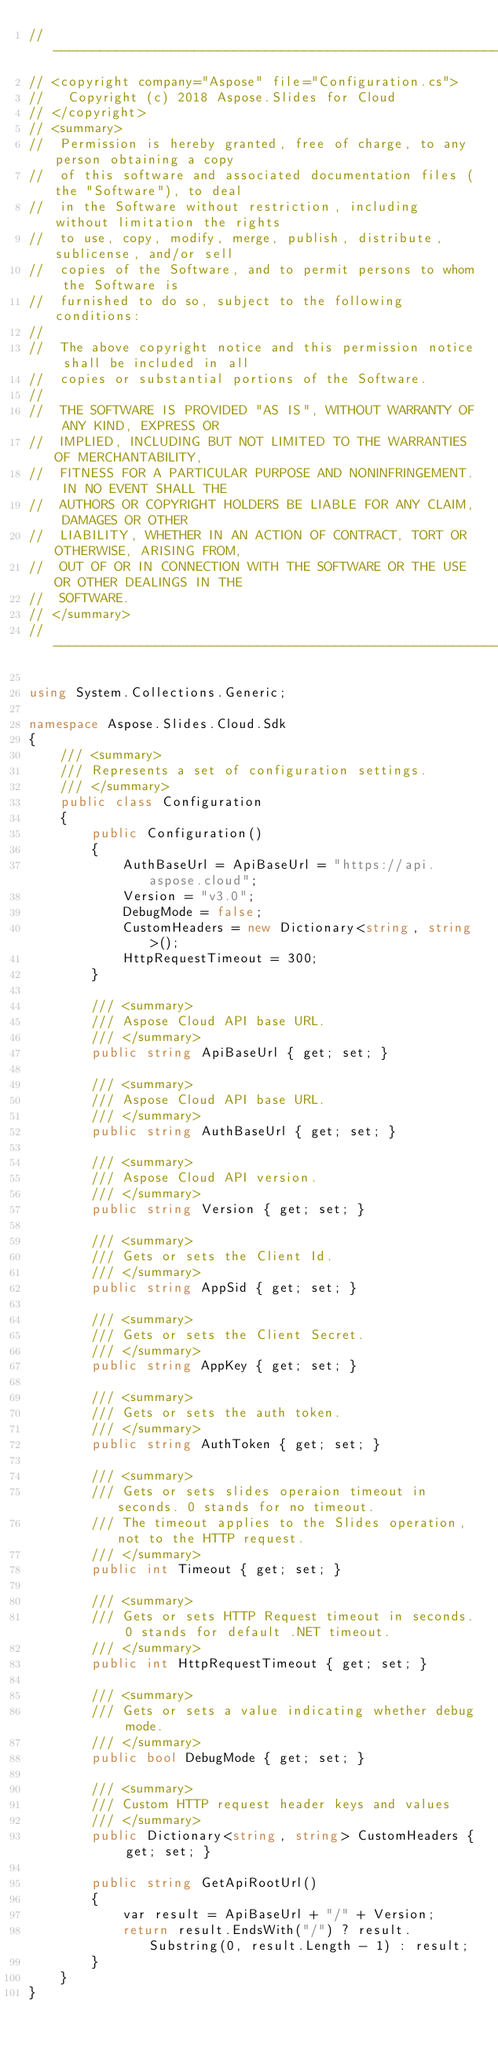<code> <loc_0><loc_0><loc_500><loc_500><_C#_>// --------------------------------------------------------------------------------------------------------------------
// <copyright company="Aspose" file="Configuration.cs">
//   Copyright (c) 2018 Aspose.Slides for Cloud
// </copyright>
// <summary>
//  Permission is hereby granted, free of charge, to any person obtaining a copy
//  of this software and associated documentation files (the "Software"), to deal
//  in the Software without restriction, including without limitation the rights
//  to use, copy, modify, merge, publish, distribute, sublicense, and/or sell
//  copies of the Software, and to permit persons to whom the Software is
//  furnished to do so, subject to the following conditions:
// 
//  The above copyright notice and this permission notice shall be included in all
//  copies or substantial portions of the Software.
// 
//  THE SOFTWARE IS PROVIDED "AS IS", WITHOUT WARRANTY OF ANY KIND, EXPRESS OR
//  IMPLIED, INCLUDING BUT NOT LIMITED TO THE WARRANTIES OF MERCHANTABILITY,
//  FITNESS FOR A PARTICULAR PURPOSE AND NONINFRINGEMENT. IN NO EVENT SHALL THE
//  AUTHORS OR COPYRIGHT HOLDERS BE LIABLE FOR ANY CLAIM, DAMAGES OR OTHER
//  LIABILITY, WHETHER IN AN ACTION OF CONTRACT, TORT OR OTHERWISE, ARISING FROM,
//  OUT OF OR IN CONNECTION WITH THE SOFTWARE OR THE USE OR OTHER DEALINGS IN THE
//  SOFTWARE.
// </summary>
// --------------------------------------------------------------------------------------------------------------------

using System.Collections.Generic;

namespace Aspose.Slides.Cloud.Sdk
{
    /// <summary>
    /// Represents a set of configuration settings.
    /// </summary>
    public class Configuration
    {
        public Configuration()
        {
            AuthBaseUrl = ApiBaseUrl = "https://api.aspose.cloud";
            Version = "v3.0";
            DebugMode = false;
            CustomHeaders = new Dictionary<string, string>();
            HttpRequestTimeout = 300;
        }

        /// <summary>
        /// Aspose Cloud API base URL.
        /// </summary>
        public string ApiBaseUrl { get; set; }

        /// <summary>
        /// Aspose Cloud API base URL.
        /// </summary>
        public string AuthBaseUrl { get; set; }

        /// <summary>
        /// Aspose Cloud API version.
        /// </summary>
        public string Version { get; set; }

        /// <summary>
        /// Gets or sets the Client Id.
        /// </summary>
        public string AppSid { get; set; }

        /// <summary>
        /// Gets or sets the Client Secret.
        /// </summary>
        public string AppKey { get; set; }

        /// <summary>
        /// Gets or sets the auth token.
        /// </summary>
        public string AuthToken { get; set; }

        /// <summary>
        /// Gets or sets slides operaion timeout in seconds. 0 stands for no timeout.
        /// The timeout applies to the Slides operation, not to the HTTP request.
        /// </summary>
        public int Timeout { get; set; }

        /// <summary>
        /// Gets or sets HTTP Request timeout in seconds. 0 stands for default .NET timeout.
        /// </summary>
        public int HttpRequestTimeout { get; set; }

        /// <summary>
        /// Gets or sets a value indicating whether debug mode.
        /// </summary>
        public bool DebugMode { get; set; }

        /// <summary>
        /// Custom HTTP request header keys and values
        /// </summary>
        public Dictionary<string, string> CustomHeaders { get; set; }

        public string GetApiRootUrl()
        {
            var result = ApiBaseUrl + "/" + Version;
            return result.EndsWith("/") ? result.Substring(0, result.Length - 1) : result;
        }
    }
}
</code> 